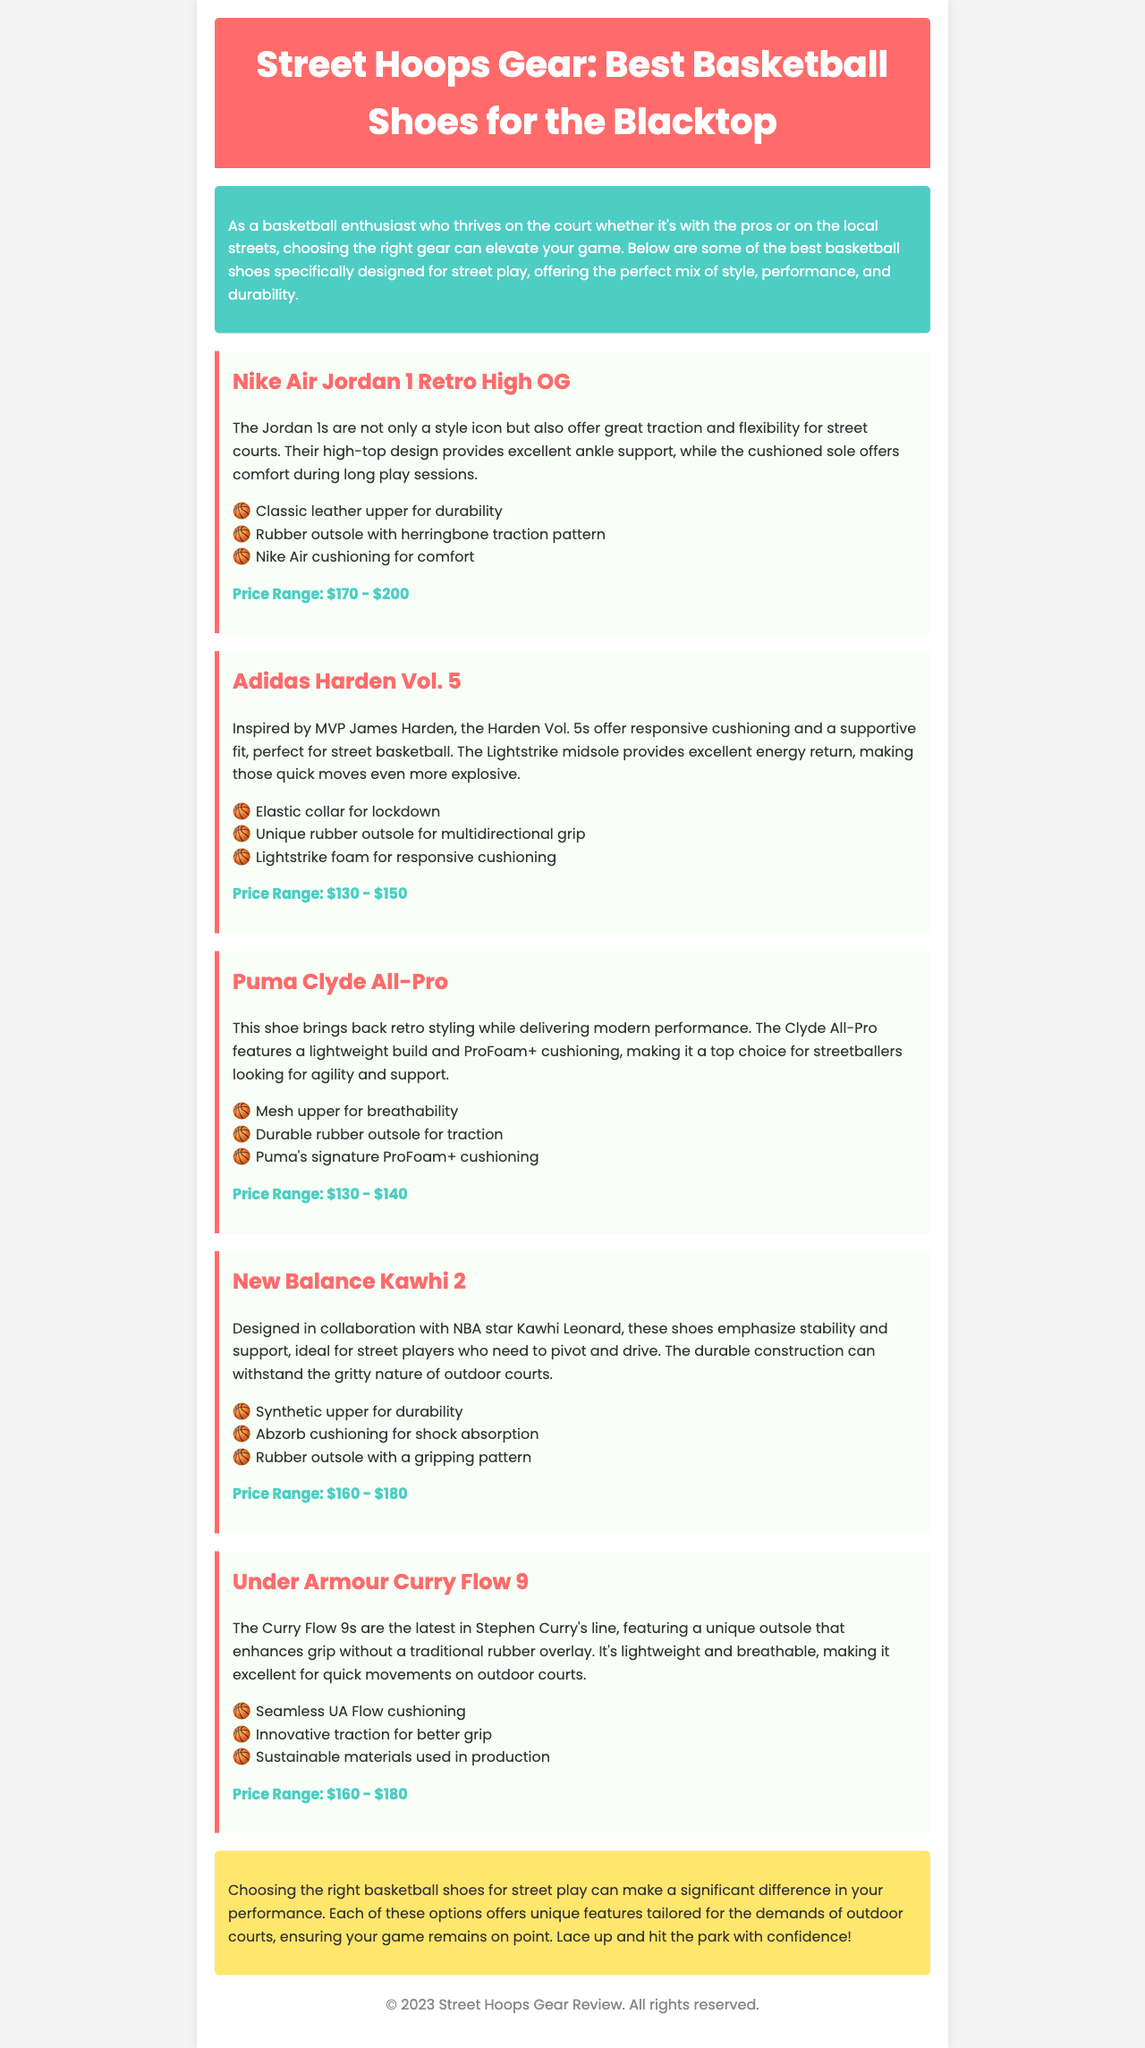What is the title of the newsletter? The title of the newsletter is found in the header section of the document.
Answer: Street Hoops Gear: Best Basketball Shoes for the Blacktop What is the price range of the Nike Air Jordan 1 Retro High OG? The price range is listed under the shoe review for the Nike Air Jordan 1 Retro High OG.
Answer: $170 - $200 Which shoe is designed in collaboration with Kawhi Leonard? The shoe designed in collaboration with Kawhi Leonard is mentioned in the corresponding shoe review section.
Answer: New Balance Kawhi 2 What feature is unique to the Under Armour Curry Flow 9? The unique feature is described in the shoe review for the Under Armour Curry Flow 9.
Answer: Unique outsole How many basketball shoes are reviewed in the document? The number of basketball shoes is counted from the individual shoe reviews provided in the document.
Answer: Five Which shoe features Lightstrike foam? The shoe that features Lightstrike foam is highlighted in the Adidas Harden Vol. 5 review.
Answer: Adidas Harden Vol. 5 What color is associated with the header background? The header background color is mentioned as part of the styling in the document.
Answer: Red What type of shoe is Puma Clyde All-Pro described as? The type of shoe is derived from the description section of the Puma Clyde All-Pro review.
Answer: Lightweight What additional content is included in the conclusion? The conclusion provides a summary and final thoughts, which are a common component of newsletters.
Answer: Performance difference 